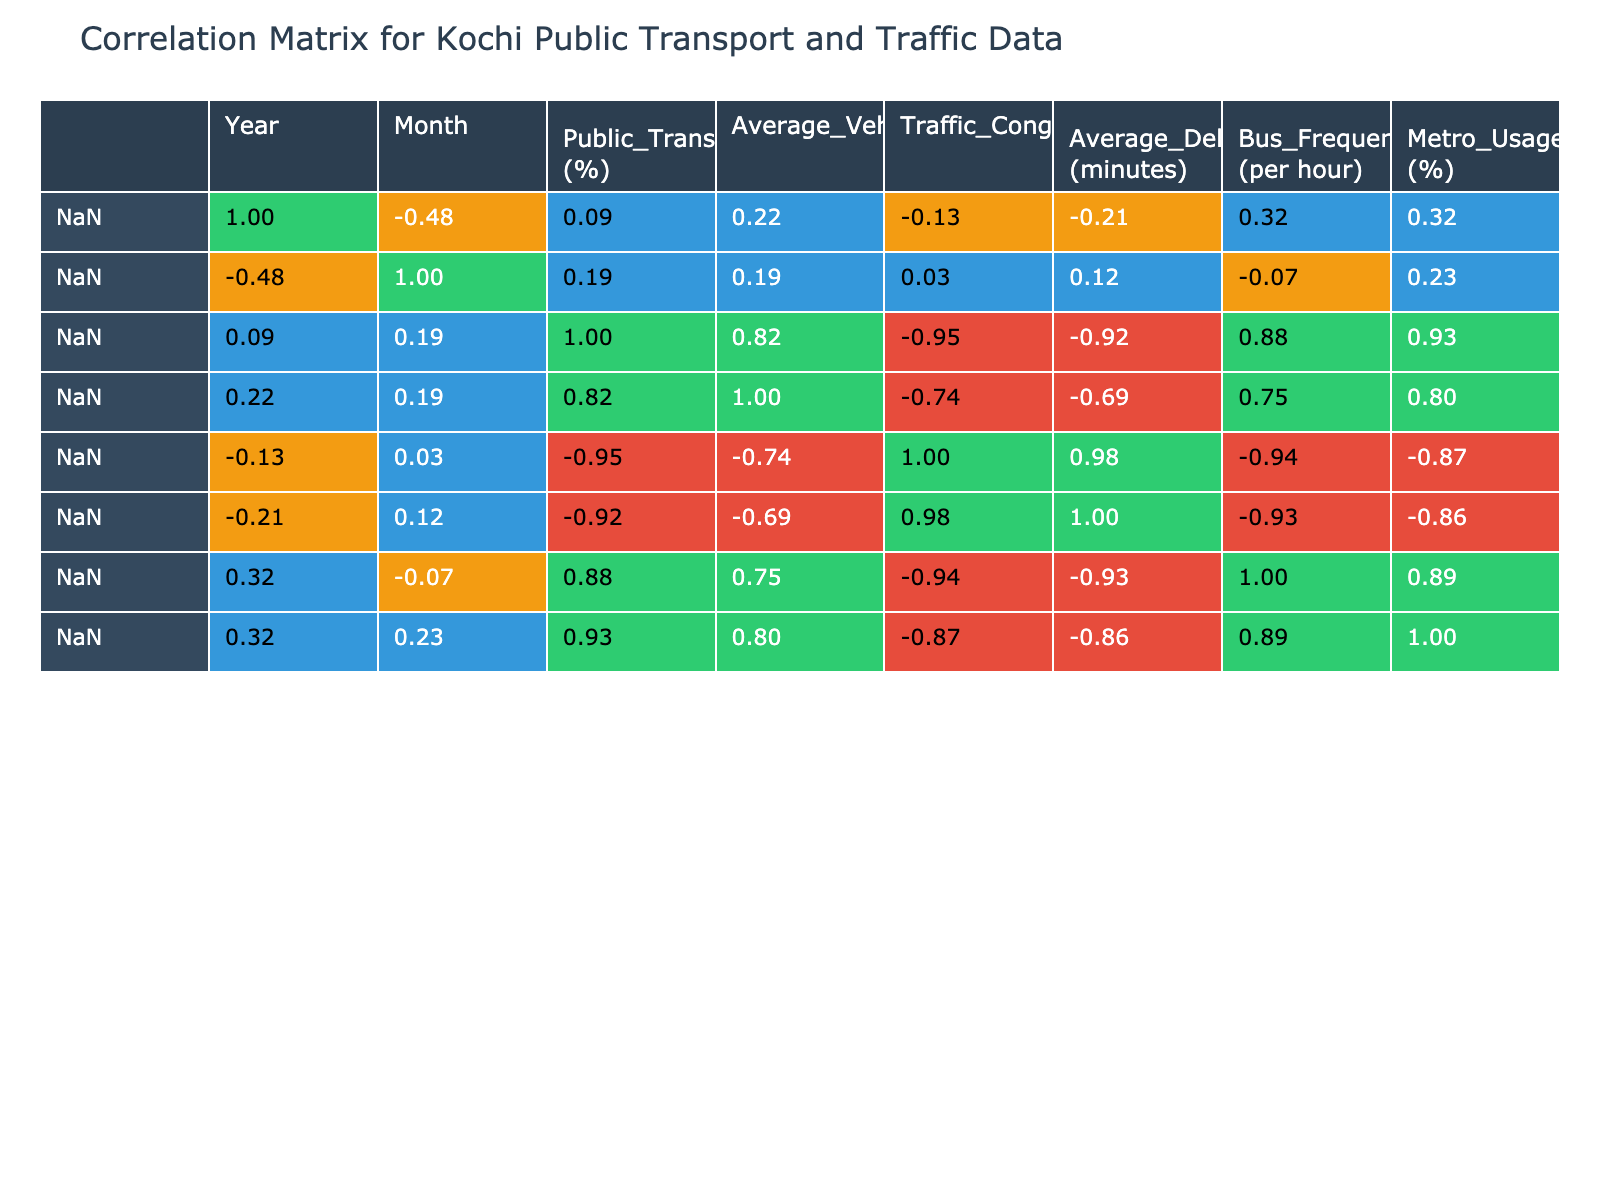What is the highest Public Transport Usage Rate recorded in the data? In the table, the Public Transport Usage Rate is listed, and by scanning through the values, the highest percentage appears in June 2022, which is 50%.
Answer: 50 What is the Traffic Congestion Index for February 2022? Referring to the table, the value for Traffic Congestion Index in February 2022 is directly accessible, and it shows a value of 65.
Answer: 65 Is there a correlation between Public Transport Usage Rate and Average Delay Time? Examining the correlation table, there is a negative correlation coefficient of approximately -0.91 between Public Transport Usage Rate and Average Delay Time, indicating that as the usage rate increases, the average delay tends to decrease.
Answer: Yes What was the average Traffic Congestion Index for the year 2022? To find the average Traffic Congestion Index for 2022, we need to sum the index values for each month (70 + 65 + 60 + 68 + 75 + 50 + 45 + 55 + 58 + 65 + 72 + 69) which totals  804, then divide by the number of months (12), yielding an average of 67.
Answer: 67 Did the Average Vehicle Count increase from January 2022 to January 2023? By comparing the Average Vehicle Count for January 2022 (15000) and January 2023 (16500), we can see that it increased by 1500 vehicles over the year.
Answer: Yes How many times per hour did buses operate in December 2022 compared to February 2023? From the table, the Bus Frequency in December 2022 is 28, and in February 2023, it is 14. To find how many more times per hour the buses operated, we calculate 28 - 14 = 14. Thus, in December 2022, buses operated 14 more times per hour than in February 2023.
Answer: 14 What is the percentage decrease in Average Delay Time from June to July 2022? The Average Delay Time in June 2022 is 25 minutes and in July 2022 it is 5 minutes. The decrease is calculated as (25 - 5) = 20 minutes, which is a decrease of 80%. We can express this as (20/25)*100 = 80%.
Answer: 80 What is the correlation between Metro Usage Rate and Average Delay Time? Looking at the correlation table, the correlation coefficient between Metro Usage Rate and Average Delay Time is approximately -0.88, indicating a strong negative correlation where higher metro usage tends to relate to lower average delay times.
Answer: Yes How many months had a Public Transport Usage Rate above 40% in 2022? By examining the Public Transport Usage Rate for each month in 2022, it is clear that the months of February, March, June, July, and August are above 40%, totaling 5 months.
Answer: 5 